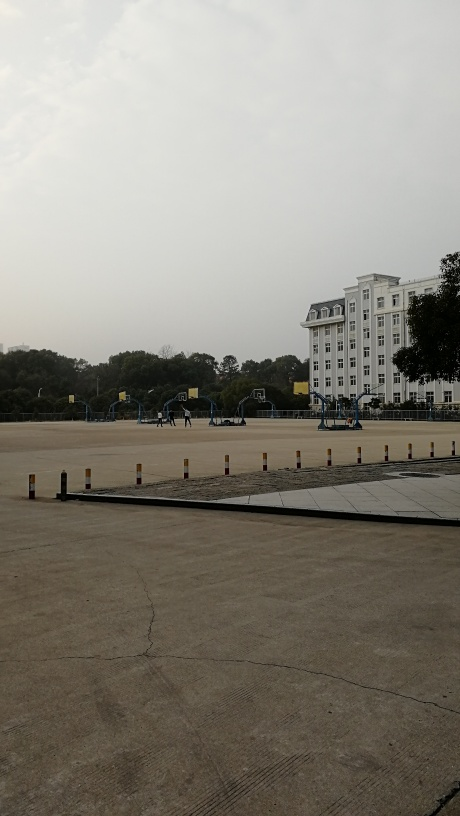What is the quality of this image considered?
A. average
B. excellent
C. poor
D. outstanding The quality of the image can be considered average, designated as option A. The image shows clear elements like the building, the basketball courts, and the sky without noticeable artifacts. However, it lacks sharpness, contrast, and dynamic range that would be characteristic of an excellent or outstanding quality image. There is also a visible tilt to the left, implying that the composition could be improved for better visual appeal. 